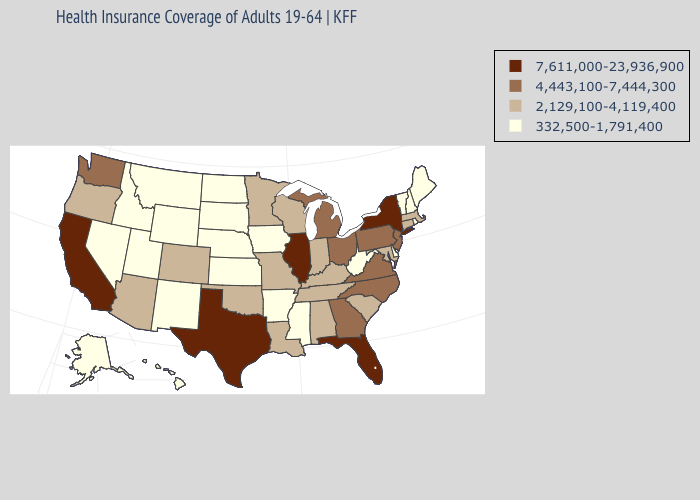Does Wisconsin have the highest value in the USA?
Write a very short answer. No. Name the states that have a value in the range 332,500-1,791,400?
Short answer required. Alaska, Arkansas, Delaware, Hawaii, Idaho, Iowa, Kansas, Maine, Mississippi, Montana, Nebraska, Nevada, New Hampshire, New Mexico, North Dakota, Rhode Island, South Dakota, Utah, Vermont, West Virginia, Wyoming. Among the states that border North Carolina , does Tennessee have the highest value?
Answer briefly. No. What is the highest value in states that border Washington?
Concise answer only. 2,129,100-4,119,400. Name the states that have a value in the range 4,443,100-7,444,300?
Answer briefly. Georgia, Michigan, New Jersey, North Carolina, Ohio, Pennsylvania, Virginia, Washington. Name the states that have a value in the range 2,129,100-4,119,400?
Answer briefly. Alabama, Arizona, Colorado, Connecticut, Indiana, Kentucky, Louisiana, Maryland, Massachusetts, Minnesota, Missouri, Oklahoma, Oregon, South Carolina, Tennessee, Wisconsin. Which states have the lowest value in the MidWest?
Concise answer only. Iowa, Kansas, Nebraska, North Dakota, South Dakota. What is the value of North Carolina?
Quick response, please. 4,443,100-7,444,300. Among the states that border Virginia , which have the lowest value?
Short answer required. West Virginia. What is the highest value in the MidWest ?
Concise answer only. 7,611,000-23,936,900. Which states have the lowest value in the West?
Short answer required. Alaska, Hawaii, Idaho, Montana, Nevada, New Mexico, Utah, Wyoming. Name the states that have a value in the range 4,443,100-7,444,300?
Quick response, please. Georgia, Michigan, New Jersey, North Carolina, Ohio, Pennsylvania, Virginia, Washington. Does Idaho have the lowest value in the West?
Keep it brief. Yes. What is the lowest value in the Northeast?
Answer briefly. 332,500-1,791,400. What is the value of Maine?
Answer briefly. 332,500-1,791,400. 